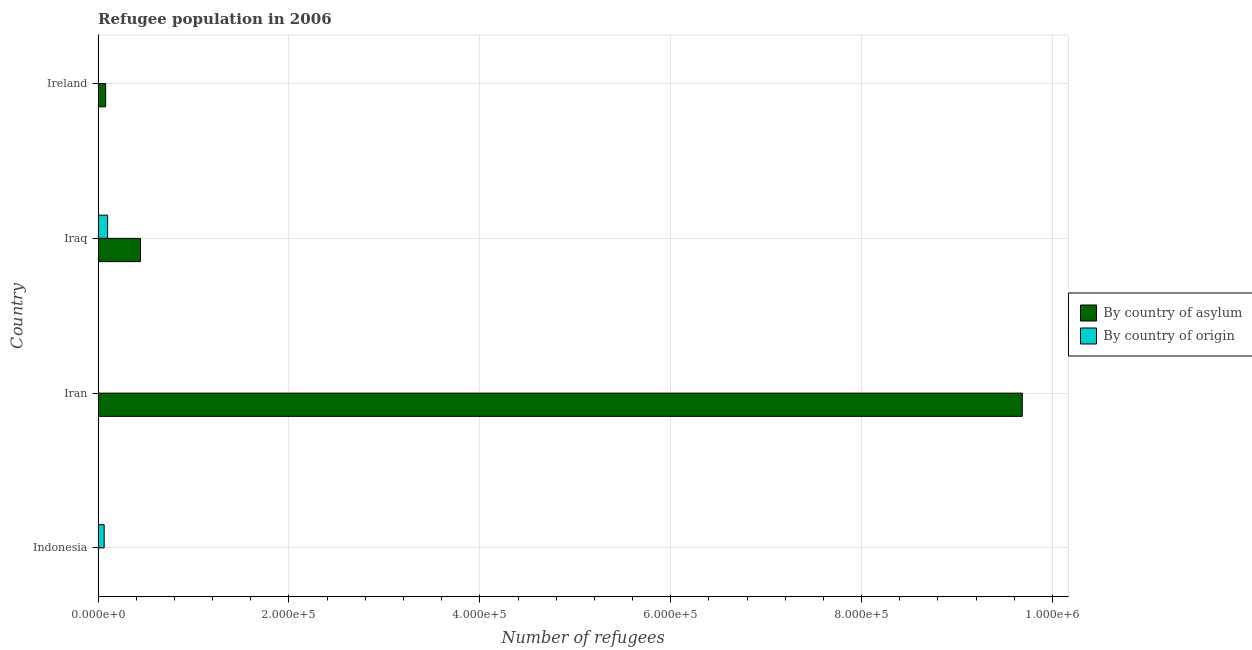Are the number of bars per tick equal to the number of legend labels?
Your response must be concise. Yes. Are the number of bars on each tick of the Y-axis equal?
Your answer should be compact. Yes. How many bars are there on the 3rd tick from the top?
Provide a short and direct response. 2. How many bars are there on the 3rd tick from the bottom?
Give a very brief answer. 2. What is the label of the 3rd group of bars from the top?
Keep it short and to the point. Iran. What is the number of refugees by country of origin in Iran?
Make the answer very short. 114. Across all countries, what is the maximum number of refugees by country of asylum?
Your answer should be very brief. 9.68e+05. Across all countries, what is the minimum number of refugees by country of origin?
Give a very brief answer. 91. In which country was the number of refugees by country of origin maximum?
Offer a very short reply. Iraq. In which country was the number of refugees by country of origin minimum?
Give a very brief answer. Ireland. What is the total number of refugees by country of asylum in the graph?
Provide a short and direct response. 1.02e+06. What is the difference between the number of refugees by country of asylum in Iraq and that in Ireland?
Provide a succinct answer. 3.65e+04. What is the difference between the number of refugees by country of origin in Iran and the number of refugees by country of asylum in Indonesia?
Offer a very short reply. -187. What is the average number of refugees by country of asylum per country?
Offer a very short reply. 2.55e+05. What is the difference between the number of refugees by country of origin and number of refugees by country of asylum in Indonesia?
Ensure brevity in your answer.  6039. What is the ratio of the number of refugees by country of asylum in Indonesia to that in Iraq?
Provide a short and direct response. 0.01. What is the difference between the highest and the second highest number of refugees by country of asylum?
Give a very brief answer. 9.24e+05. What is the difference between the highest and the lowest number of refugees by country of origin?
Keep it short and to the point. 9869. Is the sum of the number of refugees by country of origin in Indonesia and Iraq greater than the maximum number of refugees by country of asylum across all countries?
Offer a very short reply. No. What does the 2nd bar from the top in Indonesia represents?
Ensure brevity in your answer.  By country of asylum. What does the 2nd bar from the bottom in Iraq represents?
Offer a terse response. By country of origin. How many bars are there?
Your answer should be very brief. 8. Are all the bars in the graph horizontal?
Offer a terse response. Yes. What is the difference between two consecutive major ticks on the X-axis?
Your response must be concise. 2.00e+05. Are the values on the major ticks of X-axis written in scientific E-notation?
Provide a succinct answer. Yes. Does the graph contain grids?
Your response must be concise. Yes. How are the legend labels stacked?
Ensure brevity in your answer.  Vertical. What is the title of the graph?
Make the answer very short. Refugee population in 2006. What is the label or title of the X-axis?
Give a very brief answer. Number of refugees. What is the Number of refugees in By country of asylum in Indonesia?
Give a very brief answer. 301. What is the Number of refugees in By country of origin in Indonesia?
Make the answer very short. 6340. What is the Number of refugees of By country of asylum in Iran?
Provide a succinct answer. 9.68e+05. What is the Number of refugees of By country of origin in Iran?
Keep it short and to the point. 114. What is the Number of refugees in By country of asylum in Iraq?
Ensure brevity in your answer.  4.44e+04. What is the Number of refugees in By country of origin in Iraq?
Offer a very short reply. 9960. What is the Number of refugees of By country of asylum in Ireland?
Your response must be concise. 7917. What is the Number of refugees in By country of origin in Ireland?
Offer a terse response. 91. Across all countries, what is the maximum Number of refugees in By country of asylum?
Make the answer very short. 9.68e+05. Across all countries, what is the maximum Number of refugees in By country of origin?
Ensure brevity in your answer.  9960. Across all countries, what is the minimum Number of refugees of By country of asylum?
Your response must be concise. 301. Across all countries, what is the minimum Number of refugees of By country of origin?
Provide a succinct answer. 91. What is the total Number of refugees of By country of asylum in the graph?
Offer a very short reply. 1.02e+06. What is the total Number of refugees of By country of origin in the graph?
Offer a very short reply. 1.65e+04. What is the difference between the Number of refugees of By country of asylum in Indonesia and that in Iran?
Provide a succinct answer. -9.68e+05. What is the difference between the Number of refugees in By country of origin in Indonesia and that in Iran?
Ensure brevity in your answer.  6226. What is the difference between the Number of refugees of By country of asylum in Indonesia and that in Iraq?
Give a very brief answer. -4.41e+04. What is the difference between the Number of refugees of By country of origin in Indonesia and that in Iraq?
Make the answer very short. -3620. What is the difference between the Number of refugees in By country of asylum in Indonesia and that in Ireland?
Your answer should be very brief. -7616. What is the difference between the Number of refugees of By country of origin in Indonesia and that in Ireland?
Keep it short and to the point. 6249. What is the difference between the Number of refugees in By country of asylum in Iran and that in Iraq?
Provide a short and direct response. 9.24e+05. What is the difference between the Number of refugees of By country of origin in Iran and that in Iraq?
Provide a succinct answer. -9846. What is the difference between the Number of refugees of By country of asylum in Iran and that in Ireland?
Provide a succinct answer. 9.60e+05. What is the difference between the Number of refugees in By country of asylum in Iraq and that in Ireland?
Your answer should be very brief. 3.65e+04. What is the difference between the Number of refugees in By country of origin in Iraq and that in Ireland?
Your response must be concise. 9869. What is the difference between the Number of refugees in By country of asylum in Indonesia and the Number of refugees in By country of origin in Iran?
Give a very brief answer. 187. What is the difference between the Number of refugees in By country of asylum in Indonesia and the Number of refugees in By country of origin in Iraq?
Your answer should be compact. -9659. What is the difference between the Number of refugees of By country of asylum in Indonesia and the Number of refugees of By country of origin in Ireland?
Your answer should be very brief. 210. What is the difference between the Number of refugees in By country of asylum in Iran and the Number of refugees in By country of origin in Iraq?
Provide a short and direct response. 9.58e+05. What is the difference between the Number of refugees in By country of asylum in Iran and the Number of refugees in By country of origin in Ireland?
Your response must be concise. 9.68e+05. What is the difference between the Number of refugees of By country of asylum in Iraq and the Number of refugees of By country of origin in Ireland?
Your answer should be very brief. 4.43e+04. What is the average Number of refugees of By country of asylum per country?
Your answer should be compact. 2.55e+05. What is the average Number of refugees of By country of origin per country?
Your response must be concise. 4126.25. What is the difference between the Number of refugees in By country of asylum and Number of refugees in By country of origin in Indonesia?
Keep it short and to the point. -6039. What is the difference between the Number of refugees of By country of asylum and Number of refugees of By country of origin in Iran?
Give a very brief answer. 9.68e+05. What is the difference between the Number of refugees of By country of asylum and Number of refugees of By country of origin in Iraq?
Provide a succinct answer. 3.44e+04. What is the difference between the Number of refugees in By country of asylum and Number of refugees in By country of origin in Ireland?
Ensure brevity in your answer.  7826. What is the ratio of the Number of refugees in By country of origin in Indonesia to that in Iran?
Provide a short and direct response. 55.61. What is the ratio of the Number of refugees in By country of asylum in Indonesia to that in Iraq?
Your response must be concise. 0.01. What is the ratio of the Number of refugees of By country of origin in Indonesia to that in Iraq?
Offer a terse response. 0.64. What is the ratio of the Number of refugees in By country of asylum in Indonesia to that in Ireland?
Your answer should be very brief. 0.04. What is the ratio of the Number of refugees in By country of origin in Indonesia to that in Ireland?
Your response must be concise. 69.67. What is the ratio of the Number of refugees in By country of asylum in Iran to that in Iraq?
Make the answer very short. 21.81. What is the ratio of the Number of refugees of By country of origin in Iran to that in Iraq?
Offer a terse response. 0.01. What is the ratio of the Number of refugees of By country of asylum in Iran to that in Ireland?
Your answer should be very brief. 122.32. What is the ratio of the Number of refugees in By country of origin in Iran to that in Ireland?
Offer a terse response. 1.25. What is the ratio of the Number of refugees of By country of asylum in Iraq to that in Ireland?
Provide a succinct answer. 5.61. What is the ratio of the Number of refugees of By country of origin in Iraq to that in Ireland?
Provide a short and direct response. 109.45. What is the difference between the highest and the second highest Number of refugees in By country of asylum?
Offer a very short reply. 9.24e+05. What is the difference between the highest and the second highest Number of refugees of By country of origin?
Give a very brief answer. 3620. What is the difference between the highest and the lowest Number of refugees in By country of asylum?
Your response must be concise. 9.68e+05. What is the difference between the highest and the lowest Number of refugees of By country of origin?
Offer a terse response. 9869. 